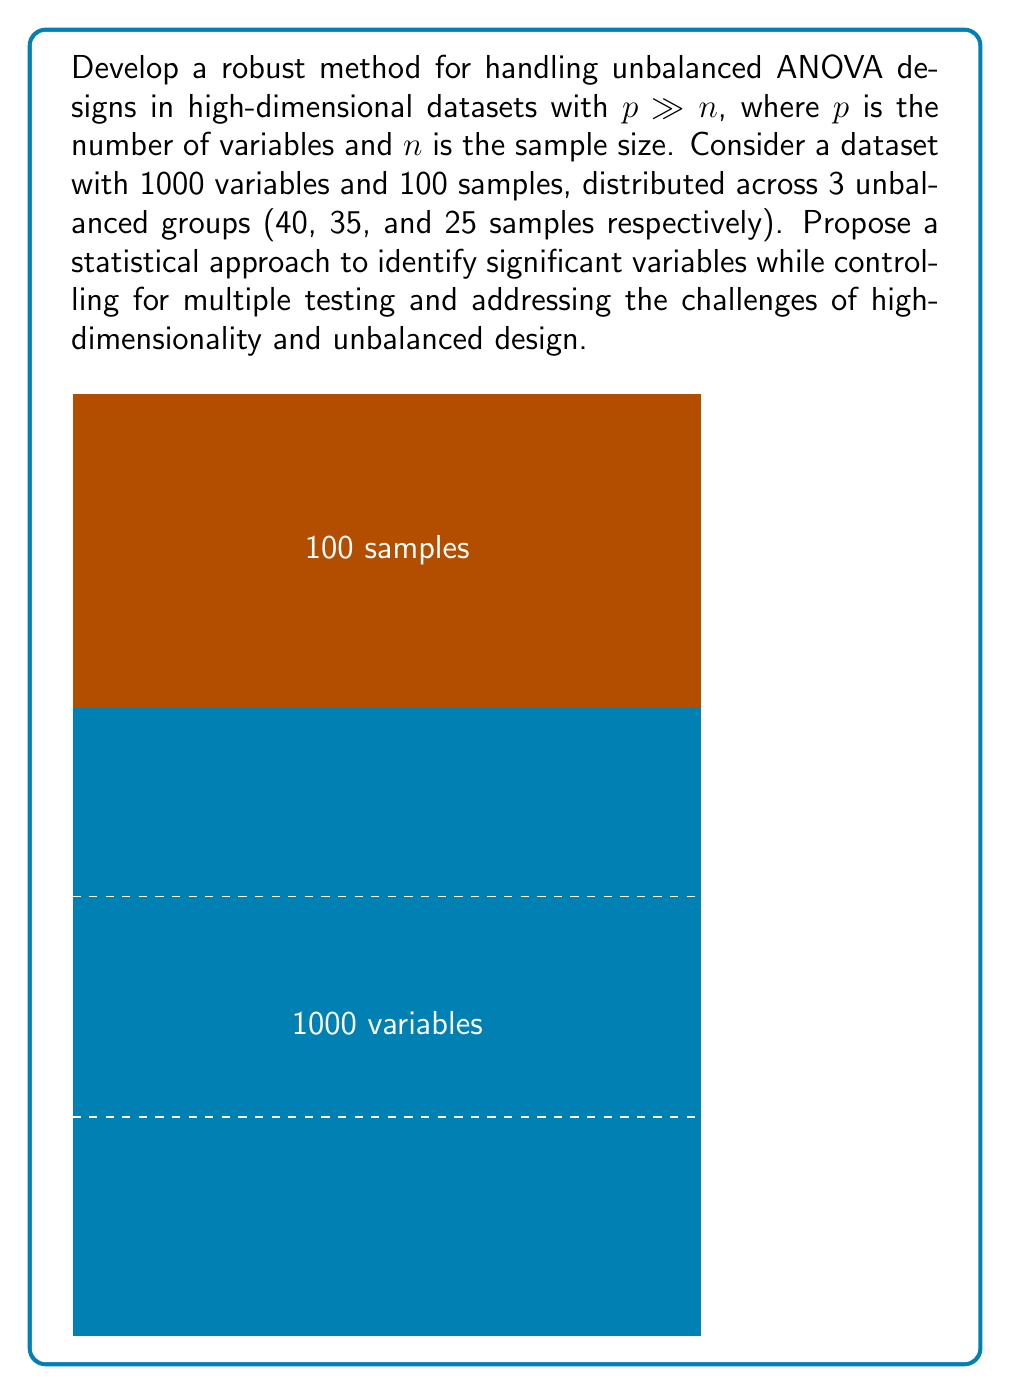Show me your answer to this math problem. To develop a robust method for handling unbalanced ANOVA designs in high-dimensional datasets, we can follow these steps:

1. Dimensionality reduction:
   Apply a dimensionality reduction technique such as Principal Component Analysis (PCA) to reduce the number of variables while retaining most of the variance. This addresses the "curse of dimensionality" issue.

   $$X_{n \times p} \rightarrow X_{n \times k}, \text{ where } k << p$$

2. Regularization:
   Implement a regularized ANOVA approach, such as elastic net regression, which combines L1 and L2 penalties:

   $$\min_{\beta} \left\{ \sum_{i=1}^n (y_i - x_i^T \beta)^2 + \lambda \left[ \alpha ||\beta||_1 + (1-\alpha) ||\beta||_2^2 \right] \right\}$$

   Where $\lambda$ is the regularization parameter and $\alpha$ balances between L1 and L2 penalties.

3. Permutation-based testing:
   Use a permutation-based approach to estimate the null distribution of test statistics, which is less sensitive to unbalanced designs:

   $$T_{obs} = \frac{\text{Between-group variability}}{\text{Within-group variability}}$$

   Compute $T_{perm}$ by randomly permuting group labels B times (e.g., B = 10000).

4. Multiple testing correction:
   Apply a multiple testing correction method such as the Benjamini-Hochberg procedure to control the False Discovery Rate (FDR):

   $$\text{FDR} = E\left[\frac{\text{False Positives}}{\text{Total Positives}}\right]$$

5. Robust estimation:
   Use robust estimators for central tendency and dispersion, such as median and median absolute deviation (MAD), to handle potential outliers:

   $$\text{MAD} = \text{median}(|X_i - \text{median}(X)|)$$

6. Variance stabilization:
   Apply a variance-stabilizing transformation (e.g., Box-Cox transformation) to address heteroscedasticity:

   $$y(\lambda) = \begin{cases}
   \frac{y^\lambda - 1}{\lambda}, & \lambda \neq 0 \\
   \log(y), & \lambda = 0
   \end{cases}$$

7. Power analysis:
   Conduct a power analysis to determine the minimum effect size that can be detected given the unbalanced design and sample sizes:

   $$\text{Power} = 1 - \beta = P(\text{Reject } H_0 | H_1 \text{ is true})$$

Implement these steps in a computational framework, such as R or Python, to create a robust pipeline for analyzing high-dimensional, unbalanced ANOVA designs.
Answer: Regularized ANOVA with PCA, permutation testing, FDR control, robust estimation, and variance stabilization 